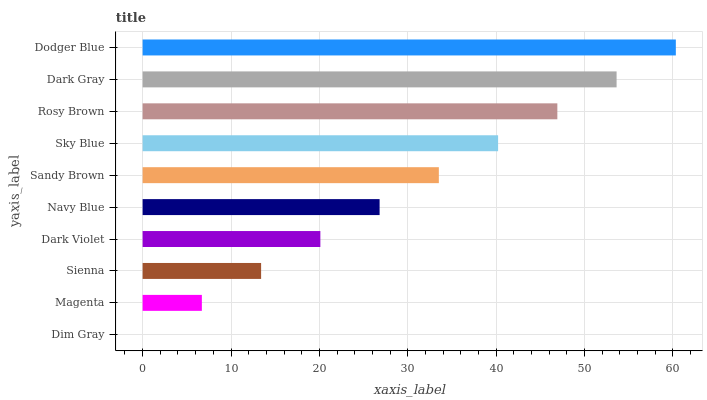Is Dim Gray the minimum?
Answer yes or no. Yes. Is Dodger Blue the maximum?
Answer yes or no. Yes. Is Magenta the minimum?
Answer yes or no. No. Is Magenta the maximum?
Answer yes or no. No. Is Magenta greater than Dim Gray?
Answer yes or no. Yes. Is Dim Gray less than Magenta?
Answer yes or no. Yes. Is Dim Gray greater than Magenta?
Answer yes or no. No. Is Magenta less than Dim Gray?
Answer yes or no. No. Is Sandy Brown the high median?
Answer yes or no. Yes. Is Navy Blue the low median?
Answer yes or no. Yes. Is Rosy Brown the high median?
Answer yes or no. No. Is Dark Gray the low median?
Answer yes or no. No. 